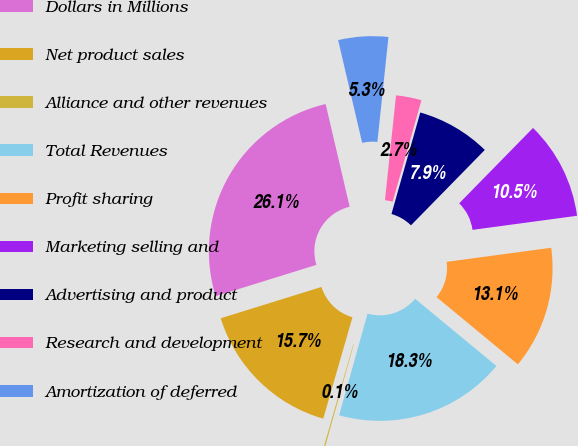Convert chart. <chart><loc_0><loc_0><loc_500><loc_500><pie_chart><fcel>Dollars in Millions<fcel>Net product sales<fcel>Alliance and other revenues<fcel>Total Revenues<fcel>Profit sharing<fcel>Marketing selling and<fcel>Advertising and product<fcel>Research and development<fcel>Amortization of deferred<nl><fcel>26.14%<fcel>15.73%<fcel>0.13%<fcel>18.34%<fcel>13.13%<fcel>10.53%<fcel>7.93%<fcel>2.73%<fcel>5.33%<nl></chart> 